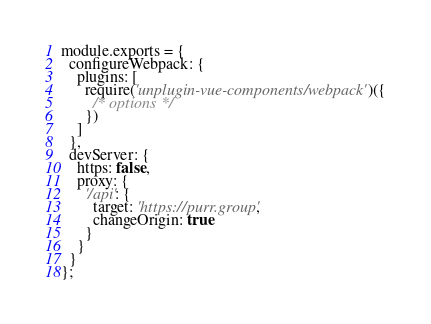Convert code to text. <code><loc_0><loc_0><loc_500><loc_500><_JavaScript_>module.exports = {
  configureWebpack: {
    plugins: [
      require('unplugin-vue-components/webpack')({
        /* options */
      })
    ]
  },
  devServer: {
    https: false,
    proxy: {
      '/api': {
        target: 'https://purr.group',
        changeOrigin: true
      }
    }
  }
};
</code> 